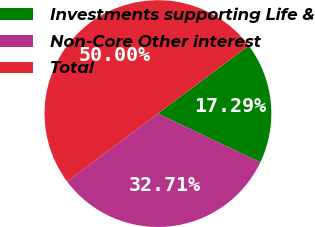<chart> <loc_0><loc_0><loc_500><loc_500><pie_chart><fcel>Investments supporting Life &<fcel>Non-Core Other interest<fcel>Total<nl><fcel>17.29%<fcel>32.71%<fcel>50.0%<nl></chart> 